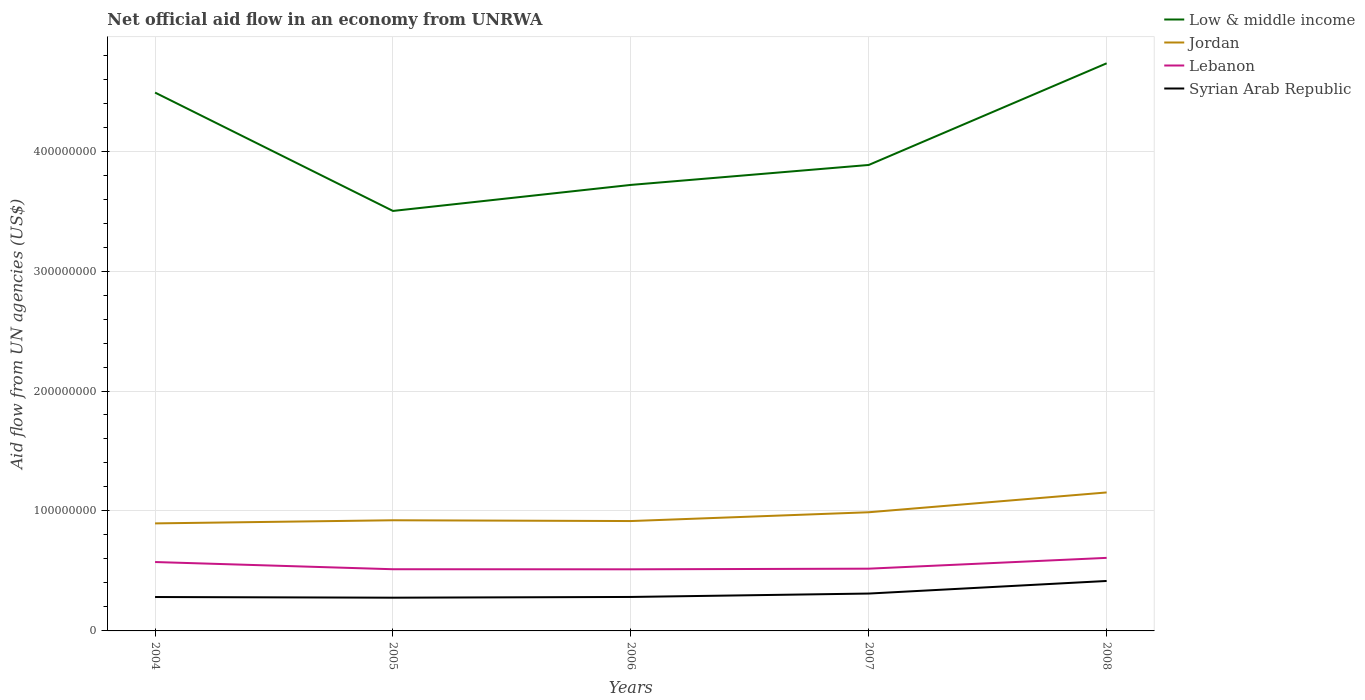Does the line corresponding to Lebanon intersect with the line corresponding to Syrian Arab Republic?
Your answer should be compact. No. Across all years, what is the maximum net official aid flow in Syrian Arab Republic?
Give a very brief answer. 2.77e+07. In which year was the net official aid flow in Lebanon maximum?
Make the answer very short. 2006. What is the total net official aid flow in Jordan in the graph?
Give a very brief answer. -2.38e+07. What is the difference between the highest and the second highest net official aid flow in Low & middle income?
Ensure brevity in your answer.  1.23e+08. Is the net official aid flow in Jordan strictly greater than the net official aid flow in Low & middle income over the years?
Keep it short and to the point. Yes. What is the difference between two consecutive major ticks on the Y-axis?
Offer a very short reply. 1.00e+08. Are the values on the major ticks of Y-axis written in scientific E-notation?
Provide a succinct answer. No. Does the graph contain grids?
Provide a short and direct response. Yes. Where does the legend appear in the graph?
Keep it short and to the point. Top right. How many legend labels are there?
Give a very brief answer. 4. What is the title of the graph?
Your answer should be compact. Net official aid flow in an economy from UNRWA. Does "Iran" appear as one of the legend labels in the graph?
Offer a terse response. No. What is the label or title of the X-axis?
Your response must be concise. Years. What is the label or title of the Y-axis?
Your response must be concise. Aid flow from UN agencies (US$). What is the Aid flow from UN agencies (US$) in Low & middle income in 2004?
Make the answer very short. 4.49e+08. What is the Aid flow from UN agencies (US$) of Jordan in 2004?
Provide a short and direct response. 8.96e+07. What is the Aid flow from UN agencies (US$) of Lebanon in 2004?
Provide a succinct answer. 5.74e+07. What is the Aid flow from UN agencies (US$) in Syrian Arab Republic in 2004?
Your response must be concise. 2.83e+07. What is the Aid flow from UN agencies (US$) of Low & middle income in 2005?
Provide a succinct answer. 3.50e+08. What is the Aid flow from UN agencies (US$) of Jordan in 2005?
Keep it short and to the point. 9.22e+07. What is the Aid flow from UN agencies (US$) in Lebanon in 2005?
Your answer should be compact. 5.14e+07. What is the Aid flow from UN agencies (US$) in Syrian Arab Republic in 2005?
Ensure brevity in your answer.  2.77e+07. What is the Aid flow from UN agencies (US$) of Low & middle income in 2006?
Keep it short and to the point. 3.72e+08. What is the Aid flow from UN agencies (US$) in Jordan in 2006?
Your answer should be compact. 9.16e+07. What is the Aid flow from UN agencies (US$) of Lebanon in 2006?
Provide a short and direct response. 5.14e+07. What is the Aid flow from UN agencies (US$) in Syrian Arab Republic in 2006?
Your answer should be compact. 2.83e+07. What is the Aid flow from UN agencies (US$) of Low & middle income in 2007?
Your answer should be compact. 3.88e+08. What is the Aid flow from UN agencies (US$) of Jordan in 2007?
Ensure brevity in your answer.  9.89e+07. What is the Aid flow from UN agencies (US$) of Lebanon in 2007?
Provide a short and direct response. 5.19e+07. What is the Aid flow from UN agencies (US$) in Syrian Arab Republic in 2007?
Make the answer very short. 3.12e+07. What is the Aid flow from UN agencies (US$) in Low & middle income in 2008?
Keep it short and to the point. 4.73e+08. What is the Aid flow from UN agencies (US$) of Jordan in 2008?
Keep it short and to the point. 1.15e+08. What is the Aid flow from UN agencies (US$) in Lebanon in 2008?
Offer a very short reply. 6.09e+07. What is the Aid flow from UN agencies (US$) of Syrian Arab Republic in 2008?
Your answer should be compact. 4.16e+07. Across all years, what is the maximum Aid flow from UN agencies (US$) of Low & middle income?
Give a very brief answer. 4.73e+08. Across all years, what is the maximum Aid flow from UN agencies (US$) in Jordan?
Your answer should be very brief. 1.15e+08. Across all years, what is the maximum Aid flow from UN agencies (US$) of Lebanon?
Provide a succinct answer. 6.09e+07. Across all years, what is the maximum Aid flow from UN agencies (US$) of Syrian Arab Republic?
Give a very brief answer. 4.16e+07. Across all years, what is the minimum Aid flow from UN agencies (US$) in Low & middle income?
Your response must be concise. 3.50e+08. Across all years, what is the minimum Aid flow from UN agencies (US$) of Jordan?
Offer a terse response. 8.96e+07. Across all years, what is the minimum Aid flow from UN agencies (US$) of Lebanon?
Give a very brief answer. 5.14e+07. Across all years, what is the minimum Aid flow from UN agencies (US$) in Syrian Arab Republic?
Provide a short and direct response. 2.77e+07. What is the total Aid flow from UN agencies (US$) in Low & middle income in the graph?
Give a very brief answer. 2.03e+09. What is the total Aid flow from UN agencies (US$) in Jordan in the graph?
Your answer should be compact. 4.88e+08. What is the total Aid flow from UN agencies (US$) in Lebanon in the graph?
Offer a very short reply. 2.73e+08. What is the total Aid flow from UN agencies (US$) in Syrian Arab Republic in the graph?
Offer a very short reply. 1.57e+08. What is the difference between the Aid flow from UN agencies (US$) of Low & middle income in 2004 and that in 2005?
Your answer should be very brief. 9.87e+07. What is the difference between the Aid flow from UN agencies (US$) in Jordan in 2004 and that in 2005?
Keep it short and to the point. -2.61e+06. What is the difference between the Aid flow from UN agencies (US$) of Lebanon in 2004 and that in 2005?
Make the answer very short. 6.01e+06. What is the difference between the Aid flow from UN agencies (US$) of Syrian Arab Republic in 2004 and that in 2005?
Offer a very short reply. 5.50e+05. What is the difference between the Aid flow from UN agencies (US$) in Low & middle income in 2004 and that in 2006?
Your answer should be very brief. 7.70e+07. What is the difference between the Aid flow from UN agencies (US$) of Jordan in 2004 and that in 2006?
Offer a very short reply. -1.96e+06. What is the difference between the Aid flow from UN agencies (US$) of Lebanon in 2004 and that in 2006?
Give a very brief answer. 6.07e+06. What is the difference between the Aid flow from UN agencies (US$) of Low & middle income in 2004 and that in 2007?
Keep it short and to the point. 6.03e+07. What is the difference between the Aid flow from UN agencies (US$) of Jordan in 2004 and that in 2007?
Your answer should be compact. -9.29e+06. What is the difference between the Aid flow from UN agencies (US$) of Lebanon in 2004 and that in 2007?
Make the answer very short. 5.54e+06. What is the difference between the Aid flow from UN agencies (US$) in Syrian Arab Republic in 2004 and that in 2007?
Offer a terse response. -2.89e+06. What is the difference between the Aid flow from UN agencies (US$) in Low & middle income in 2004 and that in 2008?
Provide a succinct answer. -2.44e+07. What is the difference between the Aid flow from UN agencies (US$) in Jordan in 2004 and that in 2008?
Your answer should be compact. -2.58e+07. What is the difference between the Aid flow from UN agencies (US$) of Lebanon in 2004 and that in 2008?
Make the answer very short. -3.47e+06. What is the difference between the Aid flow from UN agencies (US$) of Syrian Arab Republic in 2004 and that in 2008?
Make the answer very short. -1.34e+07. What is the difference between the Aid flow from UN agencies (US$) in Low & middle income in 2005 and that in 2006?
Offer a very short reply. -2.17e+07. What is the difference between the Aid flow from UN agencies (US$) of Jordan in 2005 and that in 2006?
Give a very brief answer. 6.50e+05. What is the difference between the Aid flow from UN agencies (US$) in Syrian Arab Republic in 2005 and that in 2006?
Offer a very short reply. -6.10e+05. What is the difference between the Aid flow from UN agencies (US$) in Low & middle income in 2005 and that in 2007?
Give a very brief answer. -3.83e+07. What is the difference between the Aid flow from UN agencies (US$) in Jordan in 2005 and that in 2007?
Your response must be concise. -6.68e+06. What is the difference between the Aid flow from UN agencies (US$) of Lebanon in 2005 and that in 2007?
Provide a short and direct response. -4.70e+05. What is the difference between the Aid flow from UN agencies (US$) in Syrian Arab Republic in 2005 and that in 2007?
Your answer should be compact. -3.44e+06. What is the difference between the Aid flow from UN agencies (US$) of Low & middle income in 2005 and that in 2008?
Offer a terse response. -1.23e+08. What is the difference between the Aid flow from UN agencies (US$) in Jordan in 2005 and that in 2008?
Your answer should be compact. -2.32e+07. What is the difference between the Aid flow from UN agencies (US$) in Lebanon in 2005 and that in 2008?
Give a very brief answer. -9.48e+06. What is the difference between the Aid flow from UN agencies (US$) in Syrian Arab Republic in 2005 and that in 2008?
Offer a very short reply. -1.39e+07. What is the difference between the Aid flow from UN agencies (US$) in Low & middle income in 2006 and that in 2007?
Offer a terse response. -1.66e+07. What is the difference between the Aid flow from UN agencies (US$) of Jordan in 2006 and that in 2007?
Ensure brevity in your answer.  -7.33e+06. What is the difference between the Aid flow from UN agencies (US$) of Lebanon in 2006 and that in 2007?
Your response must be concise. -5.30e+05. What is the difference between the Aid flow from UN agencies (US$) of Syrian Arab Republic in 2006 and that in 2007?
Give a very brief answer. -2.83e+06. What is the difference between the Aid flow from UN agencies (US$) of Low & middle income in 2006 and that in 2008?
Provide a succinct answer. -1.01e+08. What is the difference between the Aid flow from UN agencies (US$) in Jordan in 2006 and that in 2008?
Provide a short and direct response. -2.38e+07. What is the difference between the Aid flow from UN agencies (US$) in Lebanon in 2006 and that in 2008?
Your response must be concise. -9.54e+06. What is the difference between the Aid flow from UN agencies (US$) in Syrian Arab Republic in 2006 and that in 2008?
Provide a succinct answer. -1.33e+07. What is the difference between the Aid flow from UN agencies (US$) in Low & middle income in 2007 and that in 2008?
Provide a short and direct response. -8.48e+07. What is the difference between the Aid flow from UN agencies (US$) in Jordan in 2007 and that in 2008?
Ensure brevity in your answer.  -1.65e+07. What is the difference between the Aid flow from UN agencies (US$) in Lebanon in 2007 and that in 2008?
Offer a very short reply. -9.01e+06. What is the difference between the Aid flow from UN agencies (US$) of Syrian Arab Republic in 2007 and that in 2008?
Your answer should be compact. -1.05e+07. What is the difference between the Aid flow from UN agencies (US$) of Low & middle income in 2004 and the Aid flow from UN agencies (US$) of Jordan in 2005?
Your answer should be compact. 3.57e+08. What is the difference between the Aid flow from UN agencies (US$) in Low & middle income in 2004 and the Aid flow from UN agencies (US$) in Lebanon in 2005?
Your answer should be compact. 3.97e+08. What is the difference between the Aid flow from UN agencies (US$) of Low & middle income in 2004 and the Aid flow from UN agencies (US$) of Syrian Arab Republic in 2005?
Offer a very short reply. 4.21e+08. What is the difference between the Aid flow from UN agencies (US$) in Jordan in 2004 and the Aid flow from UN agencies (US$) in Lebanon in 2005?
Provide a short and direct response. 3.82e+07. What is the difference between the Aid flow from UN agencies (US$) in Jordan in 2004 and the Aid flow from UN agencies (US$) in Syrian Arab Republic in 2005?
Your answer should be very brief. 6.19e+07. What is the difference between the Aid flow from UN agencies (US$) of Lebanon in 2004 and the Aid flow from UN agencies (US$) of Syrian Arab Republic in 2005?
Provide a short and direct response. 2.97e+07. What is the difference between the Aid flow from UN agencies (US$) of Low & middle income in 2004 and the Aid flow from UN agencies (US$) of Jordan in 2006?
Your answer should be very brief. 3.57e+08. What is the difference between the Aid flow from UN agencies (US$) in Low & middle income in 2004 and the Aid flow from UN agencies (US$) in Lebanon in 2006?
Offer a very short reply. 3.97e+08. What is the difference between the Aid flow from UN agencies (US$) of Low & middle income in 2004 and the Aid flow from UN agencies (US$) of Syrian Arab Republic in 2006?
Your response must be concise. 4.20e+08. What is the difference between the Aid flow from UN agencies (US$) of Jordan in 2004 and the Aid flow from UN agencies (US$) of Lebanon in 2006?
Your answer should be compact. 3.83e+07. What is the difference between the Aid flow from UN agencies (US$) of Jordan in 2004 and the Aid flow from UN agencies (US$) of Syrian Arab Republic in 2006?
Make the answer very short. 6.13e+07. What is the difference between the Aid flow from UN agencies (US$) in Lebanon in 2004 and the Aid flow from UN agencies (US$) in Syrian Arab Republic in 2006?
Your answer should be compact. 2.91e+07. What is the difference between the Aid flow from UN agencies (US$) of Low & middle income in 2004 and the Aid flow from UN agencies (US$) of Jordan in 2007?
Ensure brevity in your answer.  3.50e+08. What is the difference between the Aid flow from UN agencies (US$) of Low & middle income in 2004 and the Aid flow from UN agencies (US$) of Lebanon in 2007?
Your response must be concise. 3.97e+08. What is the difference between the Aid flow from UN agencies (US$) of Low & middle income in 2004 and the Aid flow from UN agencies (US$) of Syrian Arab Republic in 2007?
Provide a short and direct response. 4.18e+08. What is the difference between the Aid flow from UN agencies (US$) in Jordan in 2004 and the Aid flow from UN agencies (US$) in Lebanon in 2007?
Give a very brief answer. 3.78e+07. What is the difference between the Aid flow from UN agencies (US$) of Jordan in 2004 and the Aid flow from UN agencies (US$) of Syrian Arab Republic in 2007?
Provide a short and direct response. 5.85e+07. What is the difference between the Aid flow from UN agencies (US$) in Lebanon in 2004 and the Aid flow from UN agencies (US$) in Syrian Arab Republic in 2007?
Keep it short and to the point. 2.63e+07. What is the difference between the Aid flow from UN agencies (US$) of Low & middle income in 2004 and the Aid flow from UN agencies (US$) of Jordan in 2008?
Offer a terse response. 3.33e+08. What is the difference between the Aid flow from UN agencies (US$) of Low & middle income in 2004 and the Aid flow from UN agencies (US$) of Lebanon in 2008?
Give a very brief answer. 3.88e+08. What is the difference between the Aid flow from UN agencies (US$) of Low & middle income in 2004 and the Aid flow from UN agencies (US$) of Syrian Arab Republic in 2008?
Your answer should be compact. 4.07e+08. What is the difference between the Aid flow from UN agencies (US$) of Jordan in 2004 and the Aid flow from UN agencies (US$) of Lebanon in 2008?
Offer a very short reply. 2.87e+07. What is the difference between the Aid flow from UN agencies (US$) in Jordan in 2004 and the Aid flow from UN agencies (US$) in Syrian Arab Republic in 2008?
Keep it short and to the point. 4.80e+07. What is the difference between the Aid flow from UN agencies (US$) in Lebanon in 2004 and the Aid flow from UN agencies (US$) in Syrian Arab Republic in 2008?
Provide a succinct answer. 1.58e+07. What is the difference between the Aid flow from UN agencies (US$) in Low & middle income in 2005 and the Aid flow from UN agencies (US$) in Jordan in 2006?
Your response must be concise. 2.59e+08. What is the difference between the Aid flow from UN agencies (US$) of Low & middle income in 2005 and the Aid flow from UN agencies (US$) of Lebanon in 2006?
Ensure brevity in your answer.  2.99e+08. What is the difference between the Aid flow from UN agencies (US$) of Low & middle income in 2005 and the Aid flow from UN agencies (US$) of Syrian Arab Republic in 2006?
Keep it short and to the point. 3.22e+08. What is the difference between the Aid flow from UN agencies (US$) in Jordan in 2005 and the Aid flow from UN agencies (US$) in Lebanon in 2006?
Provide a short and direct response. 4.09e+07. What is the difference between the Aid flow from UN agencies (US$) in Jordan in 2005 and the Aid flow from UN agencies (US$) in Syrian Arab Republic in 2006?
Your answer should be compact. 6.39e+07. What is the difference between the Aid flow from UN agencies (US$) in Lebanon in 2005 and the Aid flow from UN agencies (US$) in Syrian Arab Republic in 2006?
Offer a terse response. 2.31e+07. What is the difference between the Aid flow from UN agencies (US$) of Low & middle income in 2005 and the Aid flow from UN agencies (US$) of Jordan in 2007?
Give a very brief answer. 2.51e+08. What is the difference between the Aid flow from UN agencies (US$) in Low & middle income in 2005 and the Aid flow from UN agencies (US$) in Lebanon in 2007?
Make the answer very short. 2.98e+08. What is the difference between the Aid flow from UN agencies (US$) of Low & middle income in 2005 and the Aid flow from UN agencies (US$) of Syrian Arab Republic in 2007?
Your answer should be compact. 3.19e+08. What is the difference between the Aid flow from UN agencies (US$) of Jordan in 2005 and the Aid flow from UN agencies (US$) of Lebanon in 2007?
Offer a terse response. 4.04e+07. What is the difference between the Aid flow from UN agencies (US$) of Jordan in 2005 and the Aid flow from UN agencies (US$) of Syrian Arab Republic in 2007?
Provide a short and direct response. 6.11e+07. What is the difference between the Aid flow from UN agencies (US$) of Lebanon in 2005 and the Aid flow from UN agencies (US$) of Syrian Arab Republic in 2007?
Offer a very short reply. 2.03e+07. What is the difference between the Aid flow from UN agencies (US$) of Low & middle income in 2005 and the Aid flow from UN agencies (US$) of Jordan in 2008?
Provide a succinct answer. 2.35e+08. What is the difference between the Aid flow from UN agencies (US$) of Low & middle income in 2005 and the Aid flow from UN agencies (US$) of Lebanon in 2008?
Give a very brief answer. 2.89e+08. What is the difference between the Aid flow from UN agencies (US$) of Low & middle income in 2005 and the Aid flow from UN agencies (US$) of Syrian Arab Republic in 2008?
Ensure brevity in your answer.  3.08e+08. What is the difference between the Aid flow from UN agencies (US$) of Jordan in 2005 and the Aid flow from UN agencies (US$) of Lebanon in 2008?
Your response must be concise. 3.14e+07. What is the difference between the Aid flow from UN agencies (US$) of Jordan in 2005 and the Aid flow from UN agencies (US$) of Syrian Arab Republic in 2008?
Your answer should be compact. 5.06e+07. What is the difference between the Aid flow from UN agencies (US$) in Lebanon in 2005 and the Aid flow from UN agencies (US$) in Syrian Arab Republic in 2008?
Offer a very short reply. 9.78e+06. What is the difference between the Aid flow from UN agencies (US$) in Low & middle income in 2006 and the Aid flow from UN agencies (US$) in Jordan in 2007?
Give a very brief answer. 2.73e+08. What is the difference between the Aid flow from UN agencies (US$) of Low & middle income in 2006 and the Aid flow from UN agencies (US$) of Lebanon in 2007?
Offer a very short reply. 3.20e+08. What is the difference between the Aid flow from UN agencies (US$) in Low & middle income in 2006 and the Aid flow from UN agencies (US$) in Syrian Arab Republic in 2007?
Offer a very short reply. 3.41e+08. What is the difference between the Aid flow from UN agencies (US$) of Jordan in 2006 and the Aid flow from UN agencies (US$) of Lebanon in 2007?
Offer a terse response. 3.97e+07. What is the difference between the Aid flow from UN agencies (US$) in Jordan in 2006 and the Aid flow from UN agencies (US$) in Syrian Arab Republic in 2007?
Ensure brevity in your answer.  6.04e+07. What is the difference between the Aid flow from UN agencies (US$) in Lebanon in 2006 and the Aid flow from UN agencies (US$) in Syrian Arab Republic in 2007?
Keep it short and to the point. 2.02e+07. What is the difference between the Aid flow from UN agencies (US$) of Low & middle income in 2006 and the Aid flow from UN agencies (US$) of Jordan in 2008?
Keep it short and to the point. 2.56e+08. What is the difference between the Aid flow from UN agencies (US$) in Low & middle income in 2006 and the Aid flow from UN agencies (US$) in Lebanon in 2008?
Your response must be concise. 3.11e+08. What is the difference between the Aid flow from UN agencies (US$) of Low & middle income in 2006 and the Aid flow from UN agencies (US$) of Syrian Arab Republic in 2008?
Make the answer very short. 3.30e+08. What is the difference between the Aid flow from UN agencies (US$) in Jordan in 2006 and the Aid flow from UN agencies (US$) in Lebanon in 2008?
Ensure brevity in your answer.  3.07e+07. What is the difference between the Aid flow from UN agencies (US$) of Jordan in 2006 and the Aid flow from UN agencies (US$) of Syrian Arab Republic in 2008?
Make the answer very short. 5.00e+07. What is the difference between the Aid flow from UN agencies (US$) in Lebanon in 2006 and the Aid flow from UN agencies (US$) in Syrian Arab Republic in 2008?
Your answer should be very brief. 9.72e+06. What is the difference between the Aid flow from UN agencies (US$) of Low & middle income in 2007 and the Aid flow from UN agencies (US$) of Jordan in 2008?
Keep it short and to the point. 2.73e+08. What is the difference between the Aid flow from UN agencies (US$) in Low & middle income in 2007 and the Aid flow from UN agencies (US$) in Lebanon in 2008?
Give a very brief answer. 3.28e+08. What is the difference between the Aid flow from UN agencies (US$) in Low & middle income in 2007 and the Aid flow from UN agencies (US$) in Syrian Arab Republic in 2008?
Provide a succinct answer. 3.47e+08. What is the difference between the Aid flow from UN agencies (US$) of Jordan in 2007 and the Aid flow from UN agencies (US$) of Lebanon in 2008?
Keep it short and to the point. 3.80e+07. What is the difference between the Aid flow from UN agencies (US$) of Jordan in 2007 and the Aid flow from UN agencies (US$) of Syrian Arab Republic in 2008?
Your response must be concise. 5.73e+07. What is the difference between the Aid flow from UN agencies (US$) of Lebanon in 2007 and the Aid flow from UN agencies (US$) of Syrian Arab Republic in 2008?
Offer a very short reply. 1.02e+07. What is the average Aid flow from UN agencies (US$) of Low & middle income per year?
Your answer should be compact. 4.06e+08. What is the average Aid flow from UN agencies (US$) in Jordan per year?
Your answer should be compact. 9.76e+07. What is the average Aid flow from UN agencies (US$) in Lebanon per year?
Your response must be concise. 5.46e+07. What is the average Aid flow from UN agencies (US$) in Syrian Arab Republic per year?
Give a very brief answer. 3.14e+07. In the year 2004, what is the difference between the Aid flow from UN agencies (US$) in Low & middle income and Aid flow from UN agencies (US$) in Jordan?
Your answer should be very brief. 3.59e+08. In the year 2004, what is the difference between the Aid flow from UN agencies (US$) of Low & middle income and Aid flow from UN agencies (US$) of Lebanon?
Ensure brevity in your answer.  3.91e+08. In the year 2004, what is the difference between the Aid flow from UN agencies (US$) in Low & middle income and Aid flow from UN agencies (US$) in Syrian Arab Republic?
Make the answer very short. 4.21e+08. In the year 2004, what is the difference between the Aid flow from UN agencies (US$) in Jordan and Aid flow from UN agencies (US$) in Lebanon?
Give a very brief answer. 3.22e+07. In the year 2004, what is the difference between the Aid flow from UN agencies (US$) in Jordan and Aid flow from UN agencies (US$) in Syrian Arab Republic?
Your response must be concise. 6.14e+07. In the year 2004, what is the difference between the Aid flow from UN agencies (US$) of Lebanon and Aid flow from UN agencies (US$) of Syrian Arab Republic?
Give a very brief answer. 2.92e+07. In the year 2005, what is the difference between the Aid flow from UN agencies (US$) of Low & middle income and Aid flow from UN agencies (US$) of Jordan?
Your answer should be very brief. 2.58e+08. In the year 2005, what is the difference between the Aid flow from UN agencies (US$) of Low & middle income and Aid flow from UN agencies (US$) of Lebanon?
Provide a succinct answer. 2.99e+08. In the year 2005, what is the difference between the Aid flow from UN agencies (US$) of Low & middle income and Aid flow from UN agencies (US$) of Syrian Arab Republic?
Keep it short and to the point. 3.22e+08. In the year 2005, what is the difference between the Aid flow from UN agencies (US$) in Jordan and Aid flow from UN agencies (US$) in Lebanon?
Offer a very short reply. 4.08e+07. In the year 2005, what is the difference between the Aid flow from UN agencies (US$) in Jordan and Aid flow from UN agencies (US$) in Syrian Arab Republic?
Your answer should be very brief. 6.45e+07. In the year 2005, what is the difference between the Aid flow from UN agencies (US$) in Lebanon and Aid flow from UN agencies (US$) in Syrian Arab Republic?
Provide a succinct answer. 2.37e+07. In the year 2006, what is the difference between the Aid flow from UN agencies (US$) in Low & middle income and Aid flow from UN agencies (US$) in Jordan?
Keep it short and to the point. 2.80e+08. In the year 2006, what is the difference between the Aid flow from UN agencies (US$) of Low & middle income and Aid flow from UN agencies (US$) of Lebanon?
Make the answer very short. 3.20e+08. In the year 2006, what is the difference between the Aid flow from UN agencies (US$) in Low & middle income and Aid flow from UN agencies (US$) in Syrian Arab Republic?
Make the answer very short. 3.43e+08. In the year 2006, what is the difference between the Aid flow from UN agencies (US$) in Jordan and Aid flow from UN agencies (US$) in Lebanon?
Offer a terse response. 4.02e+07. In the year 2006, what is the difference between the Aid flow from UN agencies (US$) of Jordan and Aid flow from UN agencies (US$) of Syrian Arab Republic?
Make the answer very short. 6.33e+07. In the year 2006, what is the difference between the Aid flow from UN agencies (US$) in Lebanon and Aid flow from UN agencies (US$) in Syrian Arab Republic?
Ensure brevity in your answer.  2.30e+07. In the year 2007, what is the difference between the Aid flow from UN agencies (US$) of Low & middle income and Aid flow from UN agencies (US$) of Jordan?
Your answer should be very brief. 2.90e+08. In the year 2007, what is the difference between the Aid flow from UN agencies (US$) in Low & middle income and Aid flow from UN agencies (US$) in Lebanon?
Offer a terse response. 3.37e+08. In the year 2007, what is the difference between the Aid flow from UN agencies (US$) of Low & middle income and Aid flow from UN agencies (US$) of Syrian Arab Republic?
Offer a very short reply. 3.57e+08. In the year 2007, what is the difference between the Aid flow from UN agencies (US$) of Jordan and Aid flow from UN agencies (US$) of Lebanon?
Provide a short and direct response. 4.70e+07. In the year 2007, what is the difference between the Aid flow from UN agencies (US$) of Jordan and Aid flow from UN agencies (US$) of Syrian Arab Republic?
Offer a very short reply. 6.78e+07. In the year 2007, what is the difference between the Aid flow from UN agencies (US$) of Lebanon and Aid flow from UN agencies (US$) of Syrian Arab Republic?
Keep it short and to the point. 2.07e+07. In the year 2008, what is the difference between the Aid flow from UN agencies (US$) in Low & middle income and Aid flow from UN agencies (US$) in Jordan?
Your answer should be compact. 3.58e+08. In the year 2008, what is the difference between the Aid flow from UN agencies (US$) in Low & middle income and Aid flow from UN agencies (US$) in Lebanon?
Give a very brief answer. 4.12e+08. In the year 2008, what is the difference between the Aid flow from UN agencies (US$) in Low & middle income and Aid flow from UN agencies (US$) in Syrian Arab Republic?
Offer a terse response. 4.32e+08. In the year 2008, what is the difference between the Aid flow from UN agencies (US$) in Jordan and Aid flow from UN agencies (US$) in Lebanon?
Provide a succinct answer. 5.45e+07. In the year 2008, what is the difference between the Aid flow from UN agencies (US$) in Jordan and Aid flow from UN agencies (US$) in Syrian Arab Republic?
Provide a succinct answer. 7.38e+07. In the year 2008, what is the difference between the Aid flow from UN agencies (US$) of Lebanon and Aid flow from UN agencies (US$) of Syrian Arab Republic?
Your answer should be compact. 1.93e+07. What is the ratio of the Aid flow from UN agencies (US$) of Low & middle income in 2004 to that in 2005?
Offer a very short reply. 1.28. What is the ratio of the Aid flow from UN agencies (US$) in Jordan in 2004 to that in 2005?
Provide a short and direct response. 0.97. What is the ratio of the Aid flow from UN agencies (US$) of Lebanon in 2004 to that in 2005?
Keep it short and to the point. 1.12. What is the ratio of the Aid flow from UN agencies (US$) of Syrian Arab Republic in 2004 to that in 2005?
Offer a very short reply. 1.02. What is the ratio of the Aid flow from UN agencies (US$) in Low & middle income in 2004 to that in 2006?
Give a very brief answer. 1.21. What is the ratio of the Aid flow from UN agencies (US$) in Jordan in 2004 to that in 2006?
Provide a short and direct response. 0.98. What is the ratio of the Aid flow from UN agencies (US$) of Lebanon in 2004 to that in 2006?
Give a very brief answer. 1.12. What is the ratio of the Aid flow from UN agencies (US$) of Low & middle income in 2004 to that in 2007?
Provide a short and direct response. 1.16. What is the ratio of the Aid flow from UN agencies (US$) in Jordan in 2004 to that in 2007?
Your answer should be very brief. 0.91. What is the ratio of the Aid flow from UN agencies (US$) of Lebanon in 2004 to that in 2007?
Ensure brevity in your answer.  1.11. What is the ratio of the Aid flow from UN agencies (US$) in Syrian Arab Republic in 2004 to that in 2007?
Keep it short and to the point. 0.91. What is the ratio of the Aid flow from UN agencies (US$) of Low & middle income in 2004 to that in 2008?
Keep it short and to the point. 0.95. What is the ratio of the Aid flow from UN agencies (US$) of Jordan in 2004 to that in 2008?
Give a very brief answer. 0.78. What is the ratio of the Aid flow from UN agencies (US$) of Lebanon in 2004 to that in 2008?
Ensure brevity in your answer.  0.94. What is the ratio of the Aid flow from UN agencies (US$) in Syrian Arab Republic in 2004 to that in 2008?
Keep it short and to the point. 0.68. What is the ratio of the Aid flow from UN agencies (US$) of Low & middle income in 2005 to that in 2006?
Give a very brief answer. 0.94. What is the ratio of the Aid flow from UN agencies (US$) of Jordan in 2005 to that in 2006?
Provide a succinct answer. 1.01. What is the ratio of the Aid flow from UN agencies (US$) of Syrian Arab Republic in 2005 to that in 2006?
Provide a short and direct response. 0.98. What is the ratio of the Aid flow from UN agencies (US$) in Low & middle income in 2005 to that in 2007?
Offer a terse response. 0.9. What is the ratio of the Aid flow from UN agencies (US$) of Jordan in 2005 to that in 2007?
Keep it short and to the point. 0.93. What is the ratio of the Aid flow from UN agencies (US$) of Lebanon in 2005 to that in 2007?
Your answer should be very brief. 0.99. What is the ratio of the Aid flow from UN agencies (US$) in Syrian Arab Republic in 2005 to that in 2007?
Make the answer very short. 0.89. What is the ratio of the Aid flow from UN agencies (US$) of Low & middle income in 2005 to that in 2008?
Offer a very short reply. 0.74. What is the ratio of the Aid flow from UN agencies (US$) of Jordan in 2005 to that in 2008?
Give a very brief answer. 0.8. What is the ratio of the Aid flow from UN agencies (US$) in Lebanon in 2005 to that in 2008?
Keep it short and to the point. 0.84. What is the ratio of the Aid flow from UN agencies (US$) in Syrian Arab Republic in 2005 to that in 2008?
Provide a short and direct response. 0.67. What is the ratio of the Aid flow from UN agencies (US$) of Low & middle income in 2006 to that in 2007?
Your response must be concise. 0.96. What is the ratio of the Aid flow from UN agencies (US$) in Jordan in 2006 to that in 2007?
Your response must be concise. 0.93. What is the ratio of the Aid flow from UN agencies (US$) in Syrian Arab Republic in 2006 to that in 2007?
Make the answer very short. 0.91. What is the ratio of the Aid flow from UN agencies (US$) in Low & middle income in 2006 to that in 2008?
Make the answer very short. 0.79. What is the ratio of the Aid flow from UN agencies (US$) of Jordan in 2006 to that in 2008?
Your response must be concise. 0.79. What is the ratio of the Aid flow from UN agencies (US$) in Lebanon in 2006 to that in 2008?
Keep it short and to the point. 0.84. What is the ratio of the Aid flow from UN agencies (US$) of Syrian Arab Republic in 2006 to that in 2008?
Your response must be concise. 0.68. What is the ratio of the Aid flow from UN agencies (US$) in Low & middle income in 2007 to that in 2008?
Provide a short and direct response. 0.82. What is the ratio of the Aid flow from UN agencies (US$) in Jordan in 2007 to that in 2008?
Provide a short and direct response. 0.86. What is the ratio of the Aid flow from UN agencies (US$) of Lebanon in 2007 to that in 2008?
Provide a succinct answer. 0.85. What is the ratio of the Aid flow from UN agencies (US$) of Syrian Arab Republic in 2007 to that in 2008?
Provide a succinct answer. 0.75. What is the difference between the highest and the second highest Aid flow from UN agencies (US$) of Low & middle income?
Provide a succinct answer. 2.44e+07. What is the difference between the highest and the second highest Aid flow from UN agencies (US$) of Jordan?
Offer a very short reply. 1.65e+07. What is the difference between the highest and the second highest Aid flow from UN agencies (US$) in Lebanon?
Keep it short and to the point. 3.47e+06. What is the difference between the highest and the second highest Aid flow from UN agencies (US$) in Syrian Arab Republic?
Provide a succinct answer. 1.05e+07. What is the difference between the highest and the lowest Aid flow from UN agencies (US$) of Low & middle income?
Your response must be concise. 1.23e+08. What is the difference between the highest and the lowest Aid flow from UN agencies (US$) in Jordan?
Provide a short and direct response. 2.58e+07. What is the difference between the highest and the lowest Aid flow from UN agencies (US$) of Lebanon?
Make the answer very short. 9.54e+06. What is the difference between the highest and the lowest Aid flow from UN agencies (US$) of Syrian Arab Republic?
Make the answer very short. 1.39e+07. 